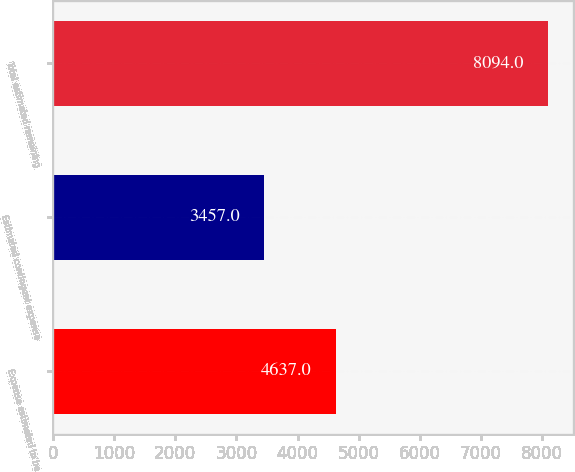Convert chart to OTSL. <chart><loc_0><loc_0><loc_500><loc_500><bar_chart><fcel>Expense estimated to be<fcel>Estimated contingent expense<fcel>Total estimated remaining<nl><fcel>4637<fcel>3457<fcel>8094<nl></chart> 